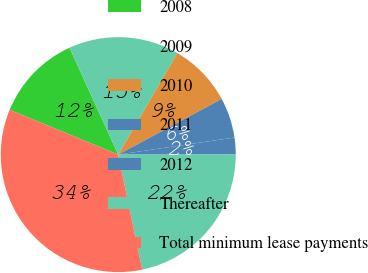Convert chart. <chart><loc_0><loc_0><loc_500><loc_500><pie_chart><fcel>2008<fcel>2009<fcel>2010<fcel>2011<fcel>2012<fcel>Thereafter<fcel>Total minimum lease payments<nl><fcel>11.97%<fcel>15.19%<fcel>8.75%<fcel>5.53%<fcel>2.31%<fcel>21.75%<fcel>34.49%<nl></chart> 